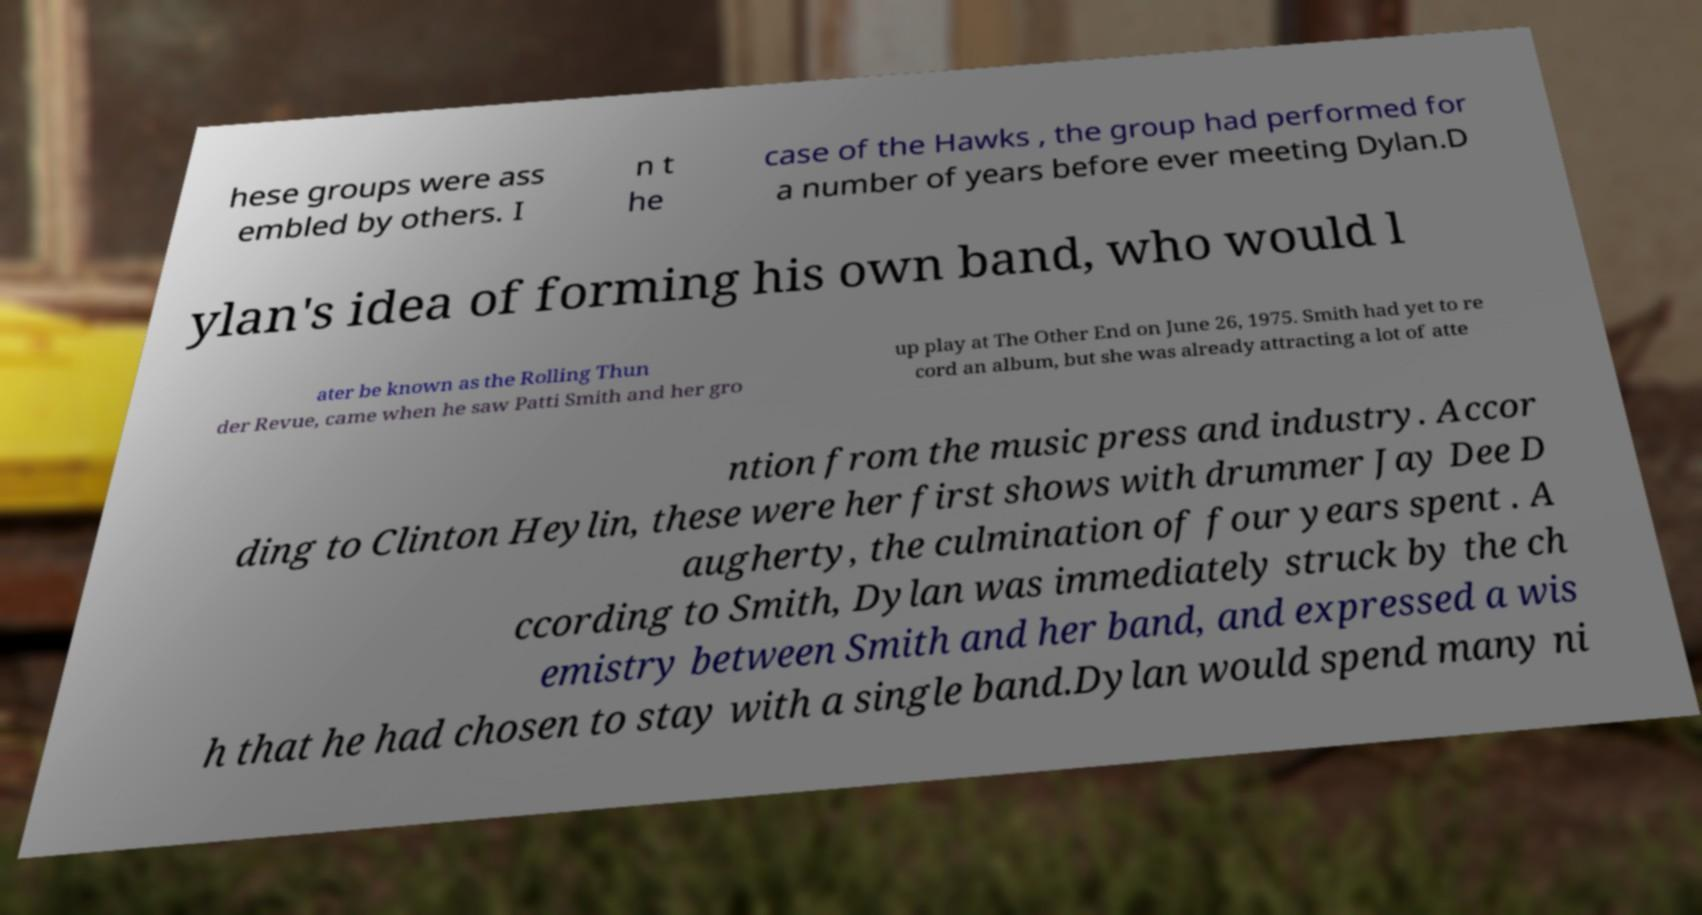Can you read and provide the text displayed in the image?This photo seems to have some interesting text. Can you extract and type it out for me? hese groups were ass embled by others. I n t he case of the Hawks , the group had performed for a number of years before ever meeting Dylan.D ylan's idea of forming his own band, who would l ater be known as the Rolling Thun der Revue, came when he saw Patti Smith and her gro up play at The Other End on June 26, 1975. Smith had yet to re cord an album, but she was already attracting a lot of atte ntion from the music press and industry. Accor ding to Clinton Heylin, these were her first shows with drummer Jay Dee D augherty, the culmination of four years spent . A ccording to Smith, Dylan was immediately struck by the ch emistry between Smith and her band, and expressed a wis h that he had chosen to stay with a single band.Dylan would spend many ni 